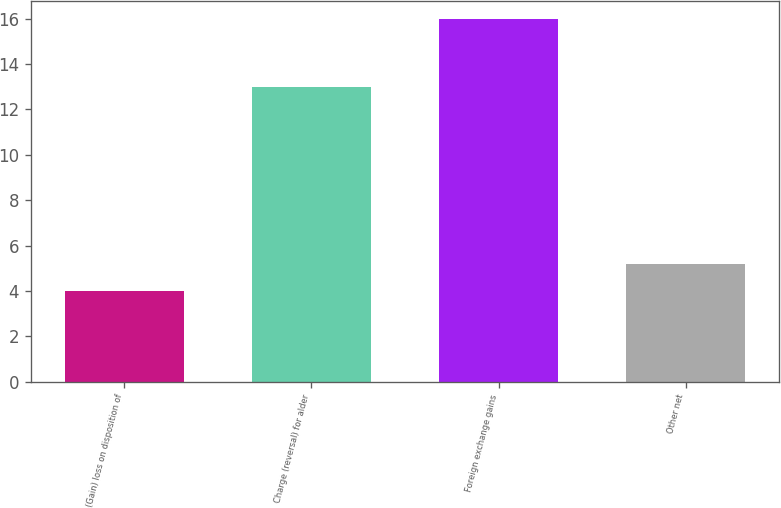Convert chart to OTSL. <chart><loc_0><loc_0><loc_500><loc_500><bar_chart><fcel>(Gain) loss on disposition of<fcel>Charge (reversal) for alder<fcel>Foreign exchange gains<fcel>Other net<nl><fcel>4<fcel>13<fcel>16<fcel>5.2<nl></chart> 